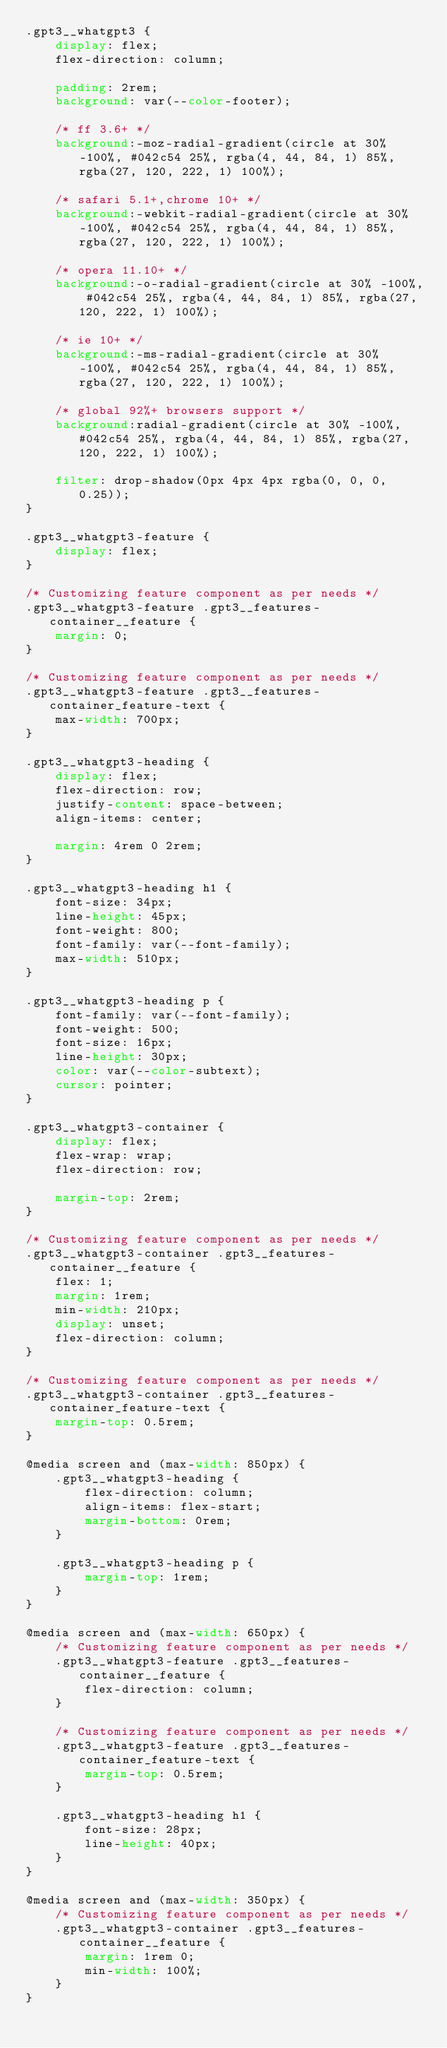<code> <loc_0><loc_0><loc_500><loc_500><_CSS_>.gpt3__whatgpt3 {
    display: flex;
    flex-direction: column;

    padding: 2rem;
    background: var(--color-footer);

    /* ff 3.6+ */
    background:-moz-radial-gradient(circle at 30% -100%, #042c54 25%, rgba(4, 44, 84, 1) 85%, rgba(27, 120, 222, 1) 100%);

    /* safari 5.1+,chrome 10+ */
    background:-webkit-radial-gradient(circle at 30% -100%, #042c54 25%, rgba(4, 44, 84, 1) 85%, rgba(27, 120, 222, 1) 100%);

    /* opera 11.10+ */
    background:-o-radial-gradient(circle at 30% -100%, #042c54 25%, rgba(4, 44, 84, 1) 85%, rgba(27, 120, 222, 1) 100%);

    /* ie 10+ */
    background:-ms-radial-gradient(circle at 30% -100%, #042c54 25%, rgba(4, 44, 84, 1) 85%, rgba(27, 120, 222, 1) 100%);

    /* global 92%+ browsers support */
    background:radial-gradient(circle at 30% -100%, #042c54 25%, rgba(4, 44, 84, 1) 85%, rgba(27, 120, 222, 1) 100%);

    filter: drop-shadow(0px 4px 4px rgba(0, 0, 0, 0.25));
}

.gpt3__whatgpt3-feature {
    display: flex;
}

/* Customizing feature component as per needs */
.gpt3__whatgpt3-feature .gpt3__features-container__feature {
    margin: 0;
}

/* Customizing feature component as per needs */
.gpt3__whatgpt3-feature .gpt3__features-container_feature-text {
    max-width: 700px;
}

.gpt3__whatgpt3-heading {
    display: flex;
    flex-direction: row;
    justify-content: space-between;
    align-items: center;
    
    margin: 4rem 0 2rem;
}

.gpt3__whatgpt3-heading h1 {
    font-size: 34px;
    line-height: 45px;
    font-weight: 800;
    font-family: var(--font-family);
    max-width: 510px;
}

.gpt3__whatgpt3-heading p {
    font-family: var(--font-family);
    font-weight: 500;
    font-size: 16px;
    line-height: 30px;
    color: var(--color-subtext);
    cursor: pointer;
}

.gpt3__whatgpt3-container {
    display: flex;
    flex-wrap: wrap;
    flex-direction: row;

    margin-top: 2rem;
}

/* Customizing feature component as per needs */
.gpt3__whatgpt3-container .gpt3__features-container__feature {
    flex: 1;
    margin: 1rem;
    min-width: 210px;
    display: unset;
    flex-direction: column;
}

/* Customizing feature component as per needs */
.gpt3__whatgpt3-container .gpt3__features-container_feature-text {
    margin-top: 0.5rem;
}

@media screen and (max-width: 850px) {
    .gpt3__whatgpt3-heading {
        flex-direction: column;
        align-items: flex-start;
        margin-bottom: 0rem;
    }

    .gpt3__whatgpt3-heading p {
        margin-top: 1rem;
    }
}

@media screen and (max-width: 650px) {
    /* Customizing feature component as per needs */
    .gpt3__whatgpt3-feature .gpt3__features-container__feature {
        flex-direction: column;
    }

    /* Customizing feature component as per needs */
    .gpt3__whatgpt3-feature .gpt3__features-container_feature-text {
        margin-top: 0.5rem;
    }

    .gpt3__whatgpt3-heading h1 {
        font-size: 28px;
        line-height: 40px;
    }
}

@media screen and (max-width: 350px) {
    /* Customizing feature component as per needs */
    .gpt3__whatgpt3-container .gpt3__features-container__feature {
        margin: 1rem 0;
        min-width: 100%;
    }
}</code> 